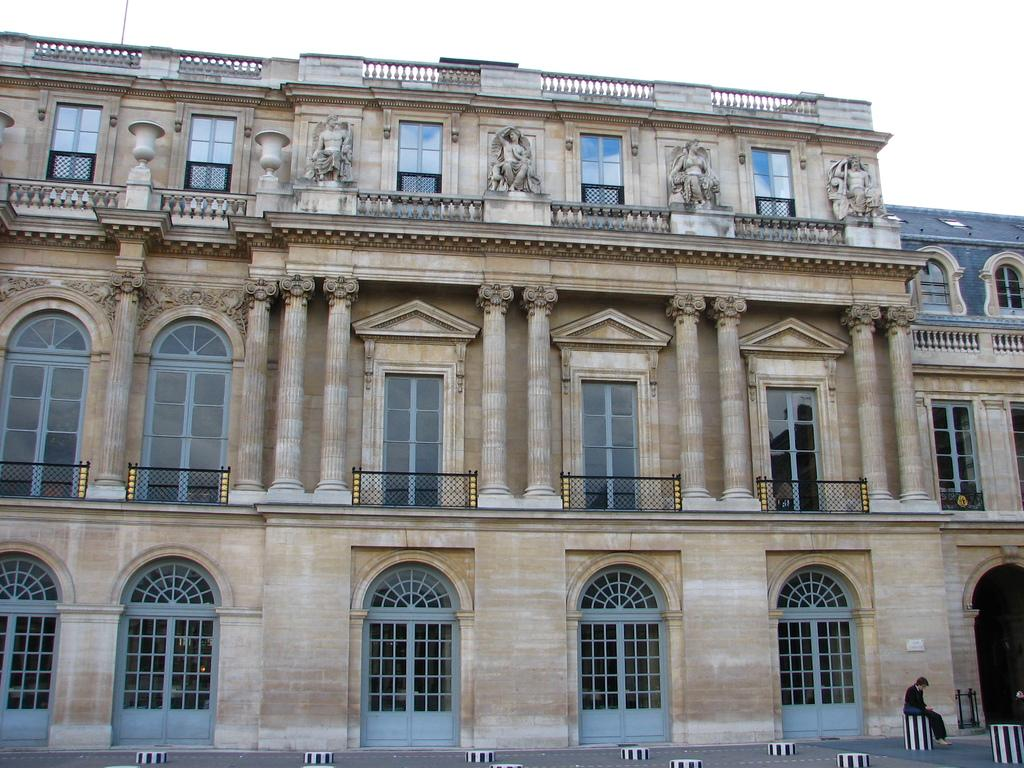What type of structure is present in the image? There is a building in the image. What architectural features can be seen on the building? The building has windows, pillars, and doors. Who is present in the image? There is a man sitting on a stool in the image. What can be seen in the background of the image? The sky is visible in the background of the image. What type of vest is the man wearing in the image? The man is not wearing a vest in the image. Can you describe the bun that the building is sitting on in the image? There is no bun present in the image; the building is standing on the ground. 